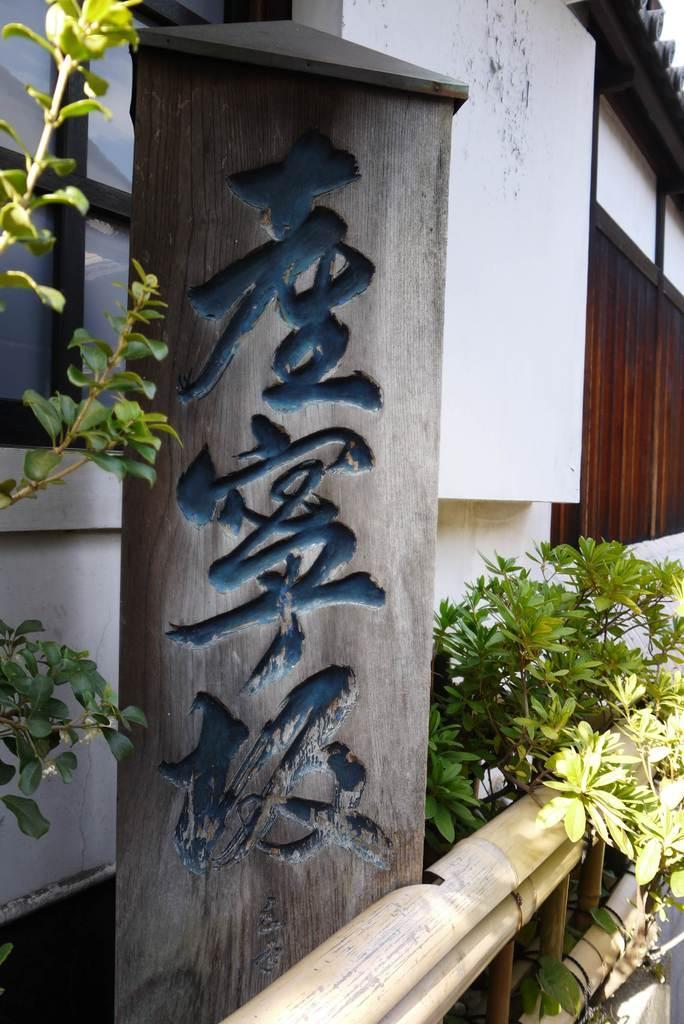Describe this image in one or two sentences. In this picture we can see house, few plants and board on which we can see some words. 